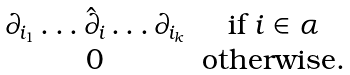Convert formula to latex. <formula><loc_0><loc_0><loc_500><loc_500>\begin{matrix} \partial _ { i _ { 1 } } \dots \hat { \partial } _ { i } \dots \partial _ { i _ { k } } & \text {if $i\in \alpha $} \\ 0 & \text {otherwise.} \end{matrix}</formula> 